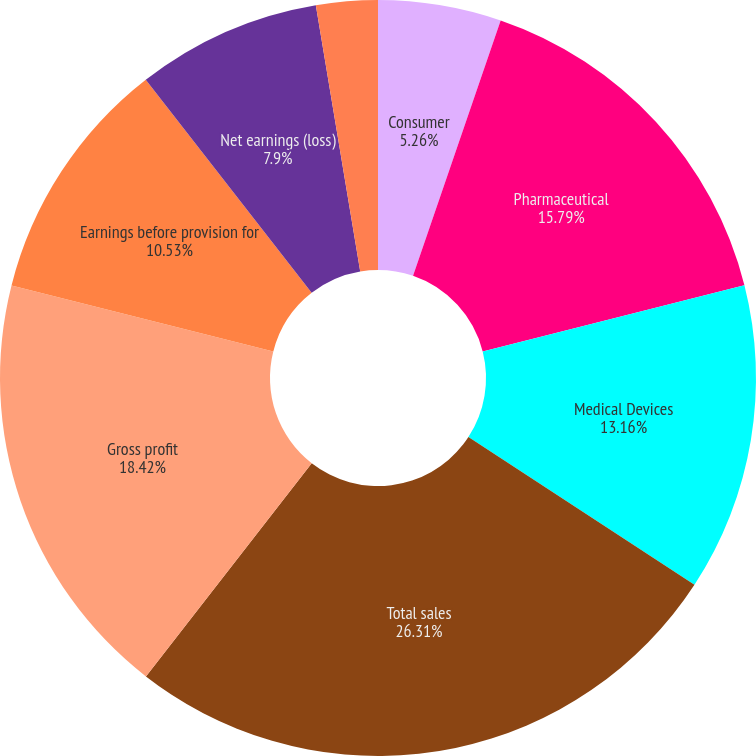<chart> <loc_0><loc_0><loc_500><loc_500><pie_chart><fcel>Consumer<fcel>Pharmaceutical<fcel>Medical Devices<fcel>Total sales<fcel>Gross profit<fcel>Earnings before provision for<fcel>Net earnings (loss)<fcel>Basic net earnings (loss) per<fcel>Diluted net earnings (loss)<nl><fcel>5.26%<fcel>15.79%<fcel>13.16%<fcel>26.31%<fcel>18.42%<fcel>10.53%<fcel>7.9%<fcel>2.63%<fcel>0.0%<nl></chart> 